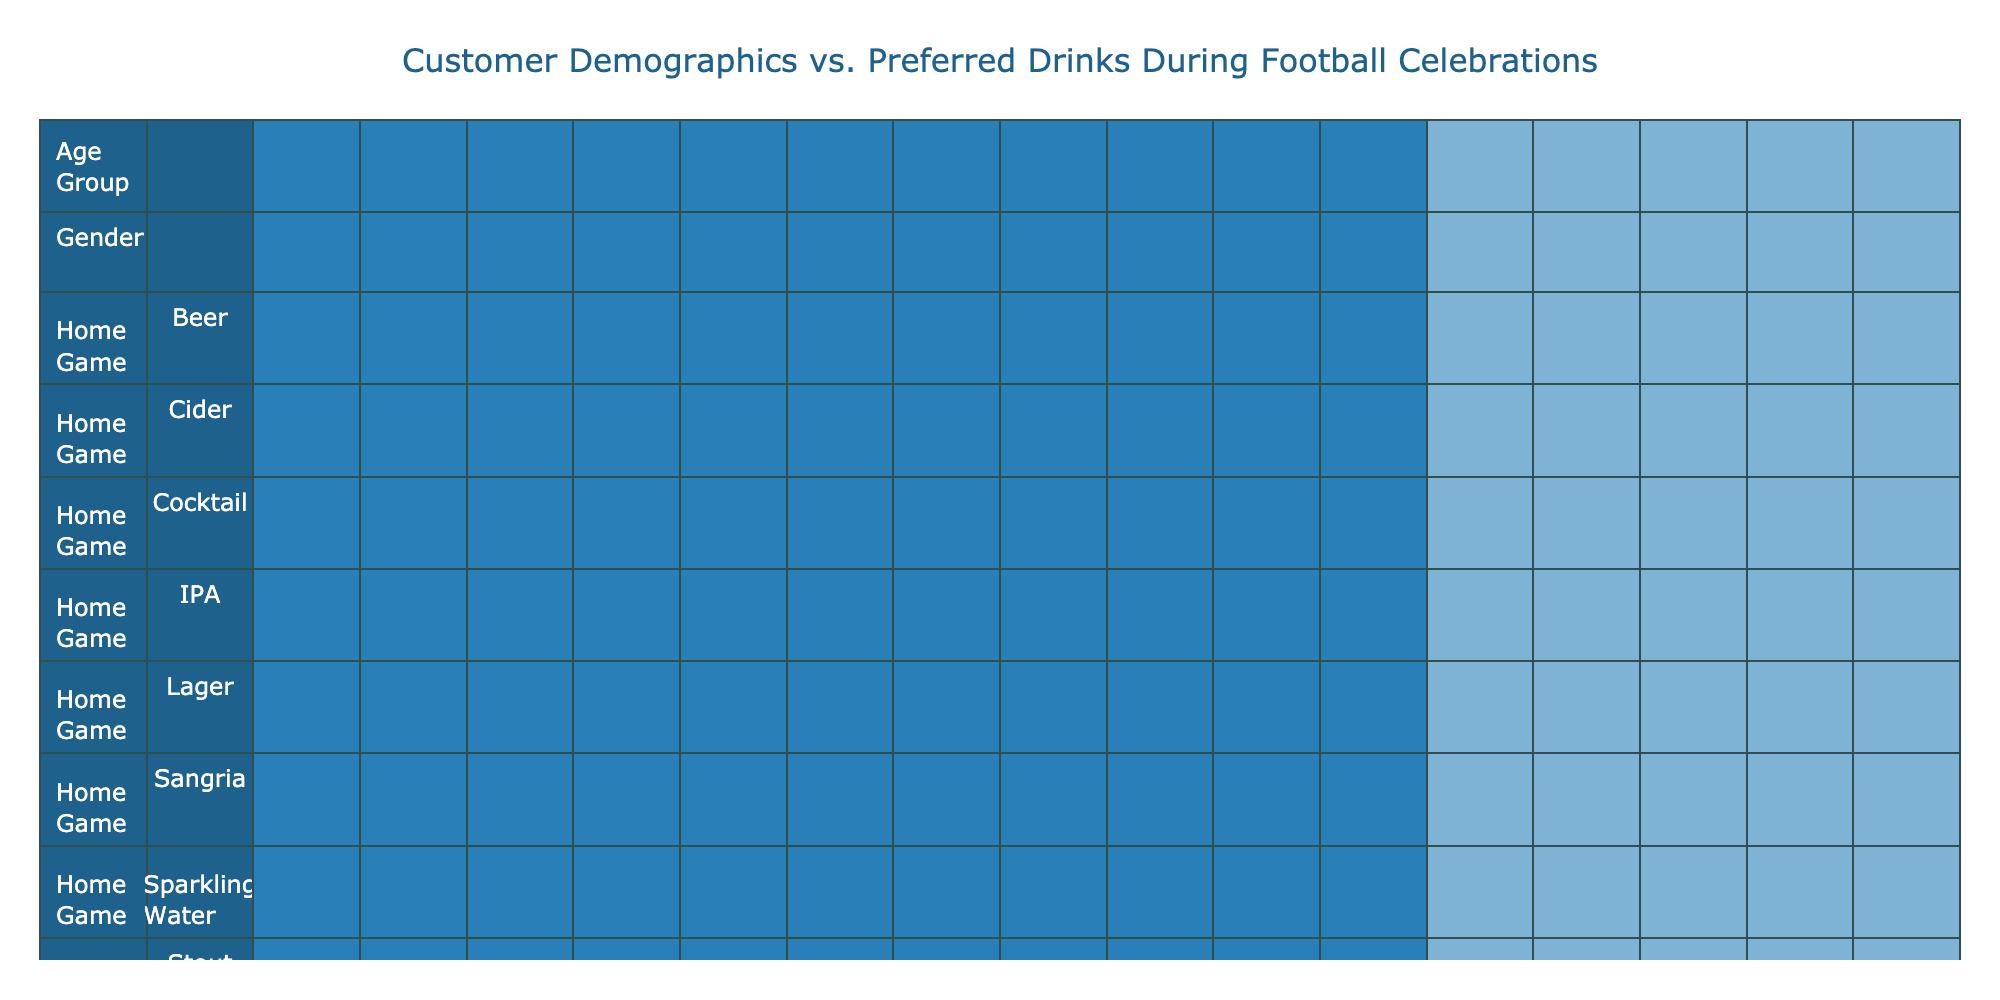What drink is most preferred by males aged 18-24 during home games? According to the table, males aged 18-24 have a preferred drink of Beer during home games, as indicated in the row for that age and gender combination under the "Home Game" column.
Answer: Beer How many females aged 35-44 prefer cider during home games? The table shows there is one entry for females aged 35-44 under the "Home Game" section, and their preferred drink is Cider. Therefore, the count is 1.
Answer: 1 Do any males aged 45-54 prefer whiskey during away games? Checking the table, males aged 45-54 have a preferred drink of Cider during away games, with no mention of whiskey in that category. Hence, the answer is no.
Answer: No What is the difference in preferred drink counts for males between home games and away games? To find the difference, we should count the number of drink preferences for males in both event types. There are 4 preferences (Beer, IPA, Stout, Lager) for home games and 4 preferences (Beer, Whiskey, Lager, Cider) for away games. The total is the same for both at 4, thus the difference is 0.
Answer: 0 Which age group has the highest variety of preferred drinks during away games? Looking at the away games section in the table, we analyze the age groups and their drink preferences. The 25-34 age group has 2 different drink preferences (Whiskey, IPA), and others have 1 or 2 as well. The age groups 35-44 and 45-54 have only 1 drink each (which is Sangria and White Wine respectively), while the 18-24 has Beer and Cocktail. Therefore, the age groups with the highest variety are 18-24 and 25-34 with 2 each.
Answer: 18-24 and 25-34 What percentage of the preferred drinks for females aged 25-34 are wine-related during home games? From the table, females aged 25-34 have a preferred drink of Wine for home games, which is 1 out of 4 total entries for females aged 25-34 (Wine and IPA). To calculate the percentage: (1/2) * 100 = 50%.
Answer: 50% 